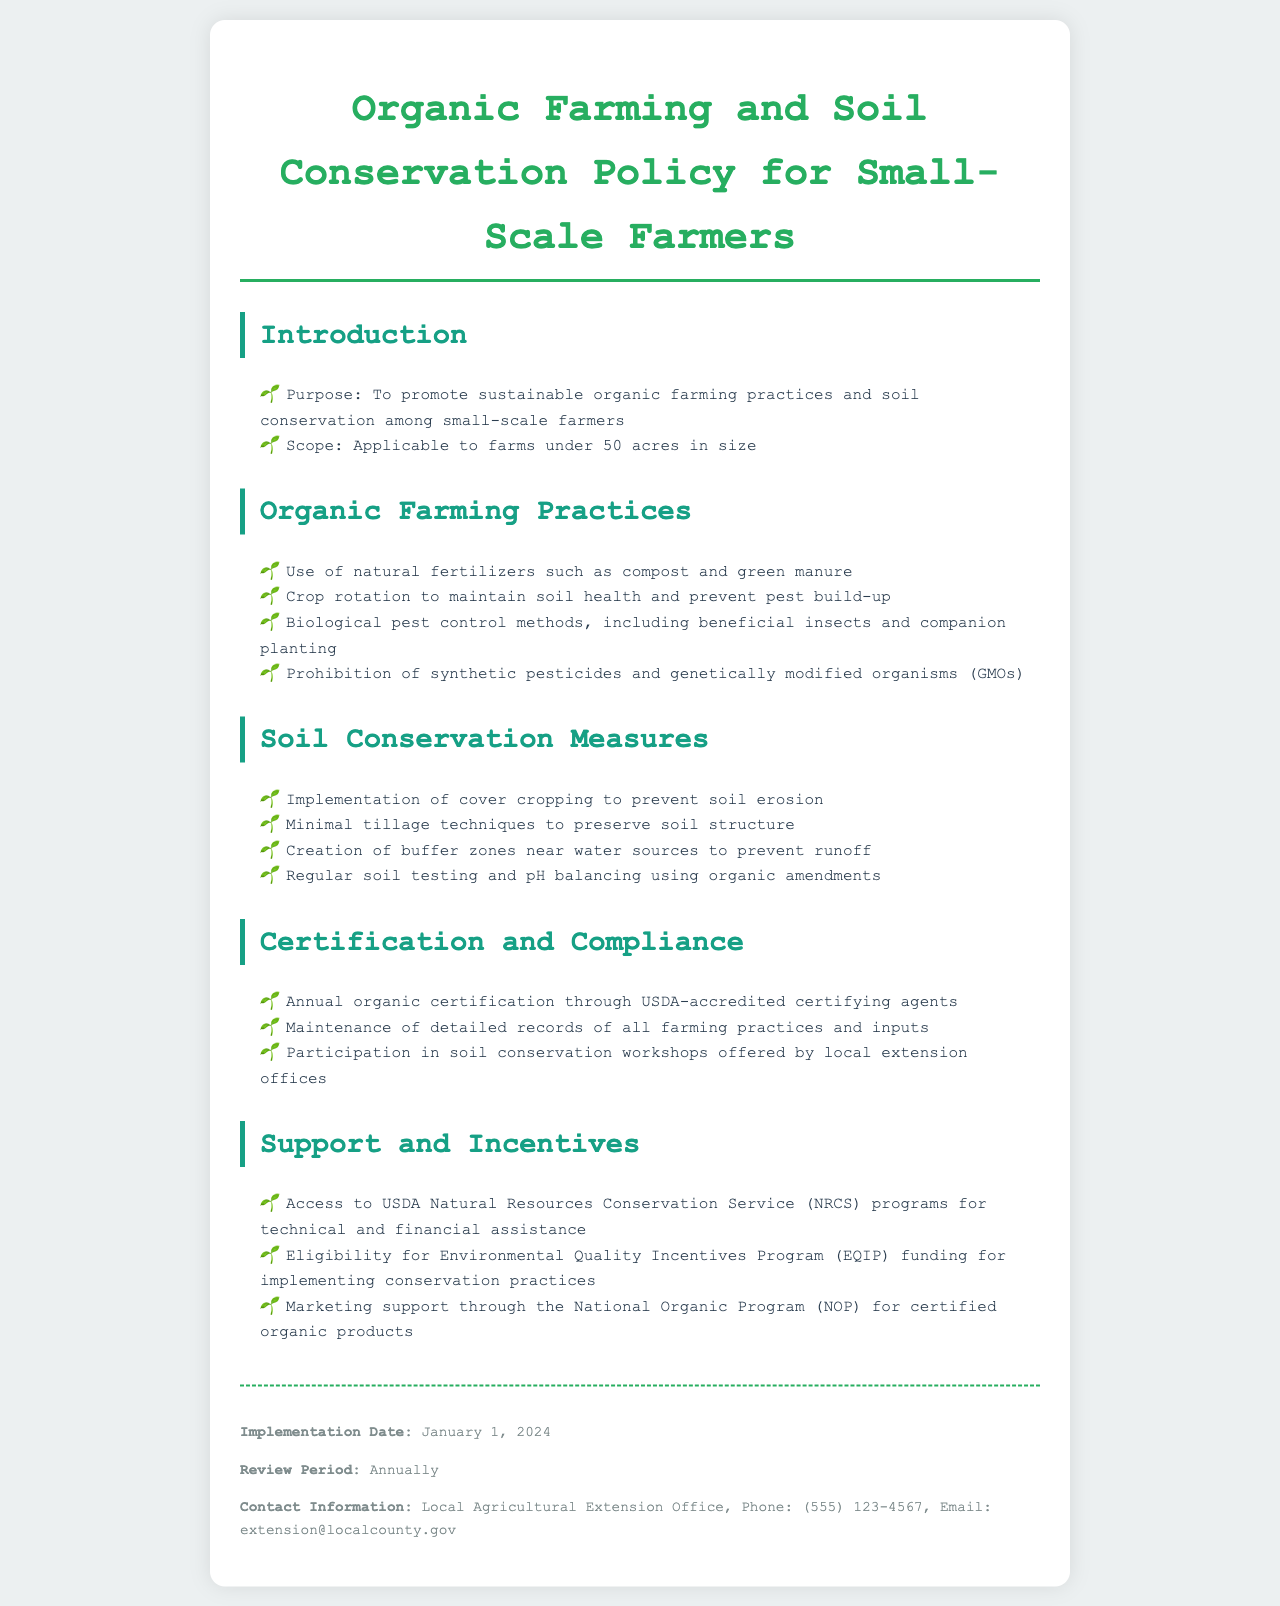what is the purpose of the policy? The purpose is to promote sustainable organic farming practices and soil conservation among small-scale farmers.
Answer: to promote sustainable organic farming practices and soil conservation among small-scale farmers what is the maximum farm size covered by this policy? The policy applies to farms under a specified size, which is indicated in the document.
Answer: 50 acres which amendment is mentioned for balancing soil pH? The document specifies a type of amendments used for balancing soil pH.
Answer: organic amendments what type of certification is required annually? The policy lists a specific type of certification needed every year for compliance.
Answer: organic certification through USDA-accredited certifying agents name one biological pest control method mentioned in the document. The document describes various pest control methods, focusing on a specific type.
Answer: beneficial insects what program can small-scale farmers access for technical and financial assistance? The policy outlines a specific program that provides support for both technical and financial needs.
Answer: USDA Natural Resources Conservation Service (NRCS) programs how often will the policy be reviewed? The document mentions a specific periodicity for reviewing the policy.
Answer: Annually what is one goal of implementing cover cropping? The document highlights several purposes of cover cropping, particularly in relation to soil management.
Answer: to prevent soil erosion 